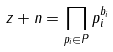<formula> <loc_0><loc_0><loc_500><loc_500>z + n = \prod _ { p _ { i } \in P } p _ { i } ^ { b _ { i } }</formula> 